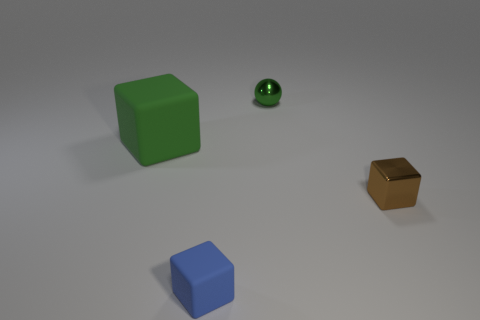How are the objects arranged in the scene? The objects are spread out across the surface, with ample space between them. They seem to be positioned deliberately, with the green cube on the left, the small green ball centrally located, and the golden cube slightly farther on the right. The blue cube is situated in the foreground. 